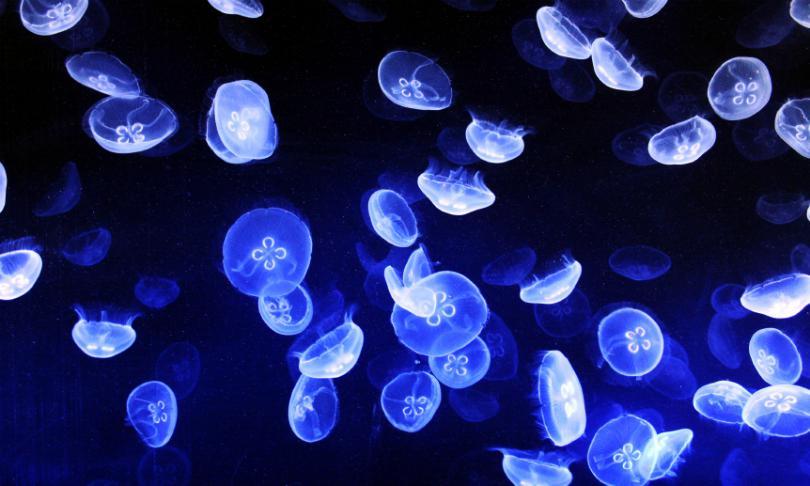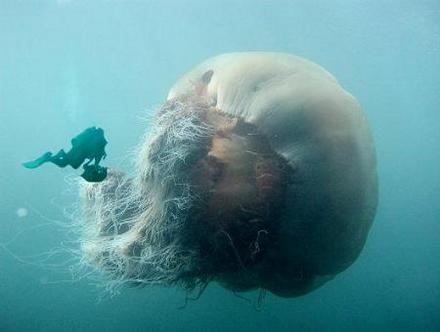The first image is the image on the left, the second image is the image on the right. For the images shown, is this caption "There is a single large jellyfish in the image on the right." true? Answer yes or no. Yes. 